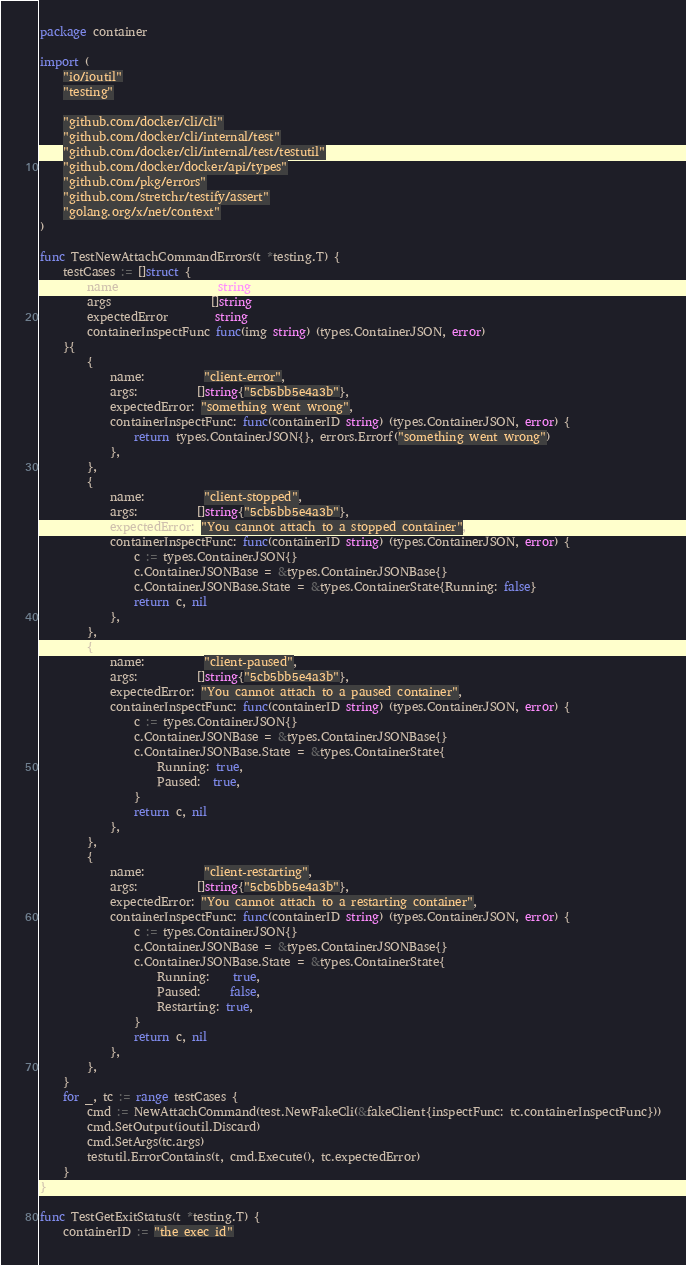<code> <loc_0><loc_0><loc_500><loc_500><_Go_>package container

import (
	"io/ioutil"
	"testing"

	"github.com/docker/cli/cli"
	"github.com/docker/cli/internal/test"
	"github.com/docker/cli/internal/test/testutil"
	"github.com/docker/docker/api/types"
	"github.com/pkg/errors"
	"github.com/stretchr/testify/assert"
	"golang.org/x/net/context"
)

func TestNewAttachCommandErrors(t *testing.T) {
	testCases := []struct {
		name                 string
		args                 []string
		expectedError        string
		containerInspectFunc func(img string) (types.ContainerJSON, error)
	}{
		{
			name:          "client-error",
			args:          []string{"5cb5bb5e4a3b"},
			expectedError: "something went wrong",
			containerInspectFunc: func(containerID string) (types.ContainerJSON, error) {
				return types.ContainerJSON{}, errors.Errorf("something went wrong")
			},
		},
		{
			name:          "client-stopped",
			args:          []string{"5cb5bb5e4a3b"},
			expectedError: "You cannot attach to a stopped container",
			containerInspectFunc: func(containerID string) (types.ContainerJSON, error) {
				c := types.ContainerJSON{}
				c.ContainerJSONBase = &types.ContainerJSONBase{}
				c.ContainerJSONBase.State = &types.ContainerState{Running: false}
				return c, nil
			},
		},
		{
			name:          "client-paused",
			args:          []string{"5cb5bb5e4a3b"},
			expectedError: "You cannot attach to a paused container",
			containerInspectFunc: func(containerID string) (types.ContainerJSON, error) {
				c := types.ContainerJSON{}
				c.ContainerJSONBase = &types.ContainerJSONBase{}
				c.ContainerJSONBase.State = &types.ContainerState{
					Running: true,
					Paused:  true,
				}
				return c, nil
			},
		},
		{
			name:          "client-restarting",
			args:          []string{"5cb5bb5e4a3b"},
			expectedError: "You cannot attach to a restarting container",
			containerInspectFunc: func(containerID string) (types.ContainerJSON, error) {
				c := types.ContainerJSON{}
				c.ContainerJSONBase = &types.ContainerJSONBase{}
				c.ContainerJSONBase.State = &types.ContainerState{
					Running:    true,
					Paused:     false,
					Restarting: true,
				}
				return c, nil
			},
		},
	}
	for _, tc := range testCases {
		cmd := NewAttachCommand(test.NewFakeCli(&fakeClient{inspectFunc: tc.containerInspectFunc}))
		cmd.SetOutput(ioutil.Discard)
		cmd.SetArgs(tc.args)
		testutil.ErrorContains(t, cmd.Execute(), tc.expectedError)
	}
}

func TestGetExitStatus(t *testing.T) {
	containerID := "the exec id"</code> 